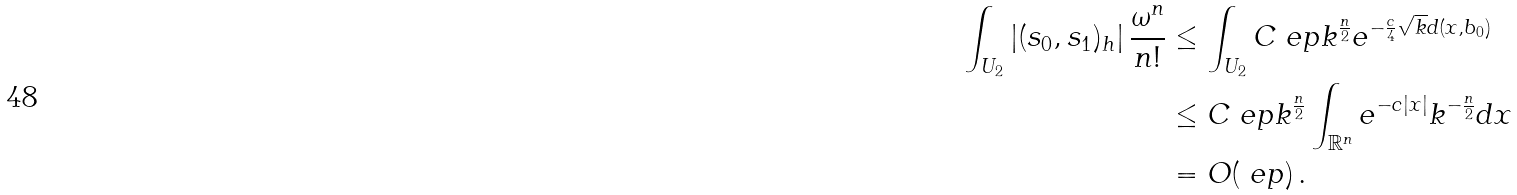Convert formula to latex. <formula><loc_0><loc_0><loc_500><loc_500>\int _ { U _ { 2 } } \left | ( s _ { 0 } , s _ { 1 } ) _ { h } \right | \frac { \omega ^ { n } } { n ! } & \leq \int _ { U _ { 2 } } C \ e p k ^ { \frac { n } { 2 } } e ^ { - \frac { c } { 4 } \sqrt { k } d ( x , b _ { 0 } ) } \\ & \leq C \ e p k ^ { \frac { n } { 2 } } \int _ { \mathbb { R } ^ { n } } e ^ { - c | x | } k ^ { - \frac { n } { 2 } } d x \\ & = O ( \ e p ) \, .</formula> 